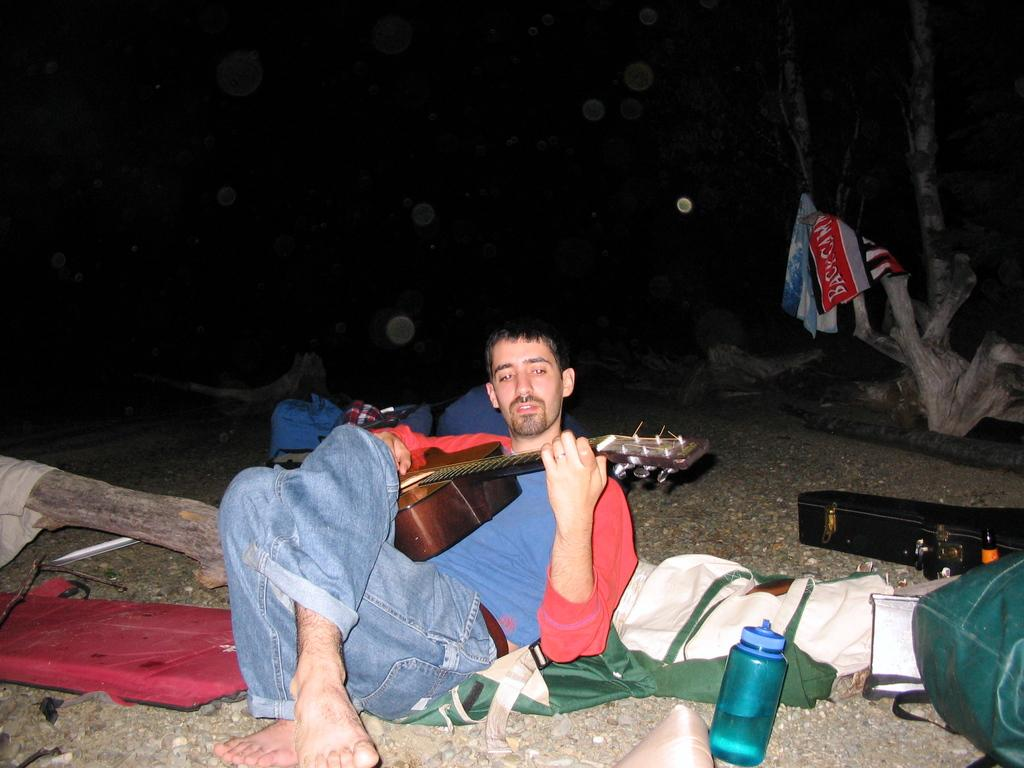What is the man in the image doing? The man in the image is playing a guitar. What objects can be seen in the image besides the man and the guitar? There is a bottle, a bag, and a piece of cloth in the image. What time is displayed on the clock in the image? There is no clock present in the image. How does the man plan to join the other musicians in the image? There are no other musicians present in the image. 